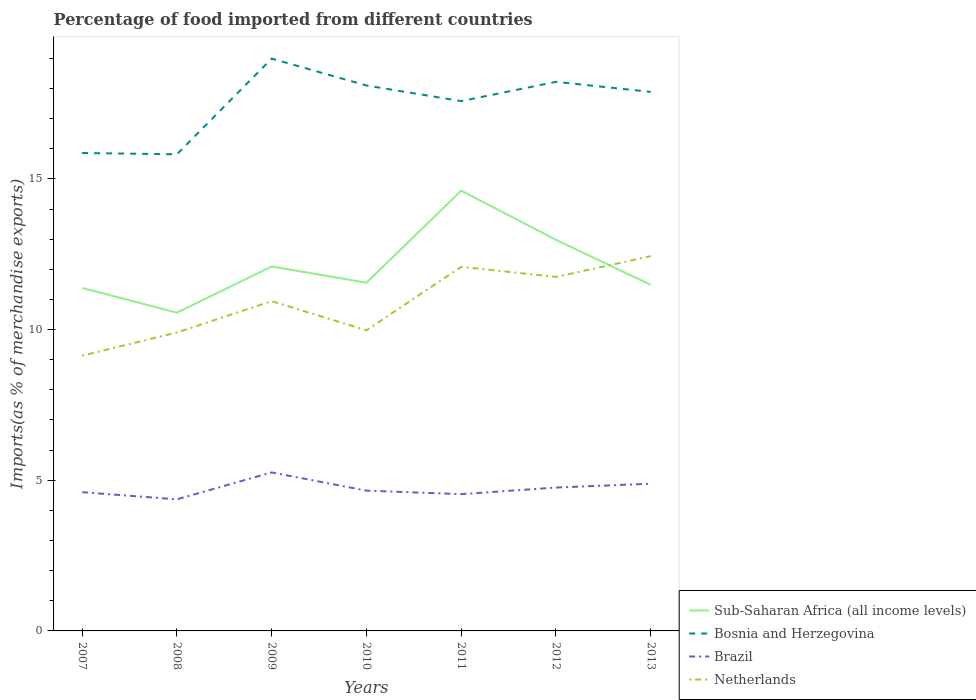Does the line corresponding to Netherlands intersect with the line corresponding to Sub-Saharan Africa (all income levels)?
Offer a very short reply. Yes. Is the number of lines equal to the number of legend labels?
Offer a very short reply. Yes. Across all years, what is the maximum percentage of imports to different countries in Brazil?
Your answer should be compact. 4.37. In which year was the percentage of imports to different countries in Bosnia and Herzegovina maximum?
Provide a short and direct response. 2008. What is the total percentage of imports to different countries in Sub-Saharan Africa (all income levels) in the graph?
Ensure brevity in your answer.  -0.17. What is the difference between the highest and the second highest percentage of imports to different countries in Sub-Saharan Africa (all income levels)?
Your answer should be very brief. 4.05. How many lines are there?
Offer a terse response. 4. How many years are there in the graph?
Make the answer very short. 7. Does the graph contain any zero values?
Provide a short and direct response. No. Does the graph contain grids?
Your answer should be compact. No. How are the legend labels stacked?
Ensure brevity in your answer.  Vertical. What is the title of the graph?
Provide a succinct answer. Percentage of food imported from different countries. What is the label or title of the X-axis?
Give a very brief answer. Years. What is the label or title of the Y-axis?
Make the answer very short. Imports(as % of merchandise exports). What is the Imports(as % of merchandise exports) of Sub-Saharan Africa (all income levels) in 2007?
Keep it short and to the point. 11.38. What is the Imports(as % of merchandise exports) in Bosnia and Herzegovina in 2007?
Offer a very short reply. 15.86. What is the Imports(as % of merchandise exports) of Brazil in 2007?
Keep it short and to the point. 4.6. What is the Imports(as % of merchandise exports) of Netherlands in 2007?
Keep it short and to the point. 9.13. What is the Imports(as % of merchandise exports) in Sub-Saharan Africa (all income levels) in 2008?
Provide a succinct answer. 10.56. What is the Imports(as % of merchandise exports) in Bosnia and Herzegovina in 2008?
Provide a short and direct response. 15.82. What is the Imports(as % of merchandise exports) of Brazil in 2008?
Provide a short and direct response. 4.37. What is the Imports(as % of merchandise exports) in Netherlands in 2008?
Your answer should be compact. 9.9. What is the Imports(as % of merchandise exports) of Sub-Saharan Africa (all income levels) in 2009?
Offer a terse response. 12.09. What is the Imports(as % of merchandise exports) in Bosnia and Herzegovina in 2009?
Offer a terse response. 18.99. What is the Imports(as % of merchandise exports) in Brazil in 2009?
Ensure brevity in your answer.  5.26. What is the Imports(as % of merchandise exports) in Netherlands in 2009?
Provide a succinct answer. 10.94. What is the Imports(as % of merchandise exports) of Sub-Saharan Africa (all income levels) in 2010?
Your answer should be very brief. 11.55. What is the Imports(as % of merchandise exports) in Bosnia and Herzegovina in 2010?
Ensure brevity in your answer.  18.1. What is the Imports(as % of merchandise exports) in Brazil in 2010?
Make the answer very short. 4.65. What is the Imports(as % of merchandise exports) of Netherlands in 2010?
Make the answer very short. 9.97. What is the Imports(as % of merchandise exports) in Sub-Saharan Africa (all income levels) in 2011?
Offer a terse response. 14.61. What is the Imports(as % of merchandise exports) of Bosnia and Herzegovina in 2011?
Your answer should be compact. 17.58. What is the Imports(as % of merchandise exports) of Brazil in 2011?
Provide a succinct answer. 4.54. What is the Imports(as % of merchandise exports) of Netherlands in 2011?
Provide a short and direct response. 12.08. What is the Imports(as % of merchandise exports) of Sub-Saharan Africa (all income levels) in 2012?
Give a very brief answer. 12.98. What is the Imports(as % of merchandise exports) in Bosnia and Herzegovina in 2012?
Provide a short and direct response. 18.22. What is the Imports(as % of merchandise exports) in Brazil in 2012?
Your response must be concise. 4.76. What is the Imports(as % of merchandise exports) in Netherlands in 2012?
Offer a very short reply. 11.75. What is the Imports(as % of merchandise exports) of Sub-Saharan Africa (all income levels) in 2013?
Provide a short and direct response. 11.48. What is the Imports(as % of merchandise exports) in Bosnia and Herzegovina in 2013?
Ensure brevity in your answer.  17.89. What is the Imports(as % of merchandise exports) in Brazil in 2013?
Give a very brief answer. 4.88. What is the Imports(as % of merchandise exports) in Netherlands in 2013?
Your answer should be very brief. 12.44. Across all years, what is the maximum Imports(as % of merchandise exports) in Sub-Saharan Africa (all income levels)?
Ensure brevity in your answer.  14.61. Across all years, what is the maximum Imports(as % of merchandise exports) in Bosnia and Herzegovina?
Provide a short and direct response. 18.99. Across all years, what is the maximum Imports(as % of merchandise exports) of Brazil?
Your answer should be compact. 5.26. Across all years, what is the maximum Imports(as % of merchandise exports) in Netherlands?
Your answer should be very brief. 12.44. Across all years, what is the minimum Imports(as % of merchandise exports) in Sub-Saharan Africa (all income levels)?
Give a very brief answer. 10.56. Across all years, what is the minimum Imports(as % of merchandise exports) in Bosnia and Herzegovina?
Ensure brevity in your answer.  15.82. Across all years, what is the minimum Imports(as % of merchandise exports) of Brazil?
Make the answer very short. 4.37. Across all years, what is the minimum Imports(as % of merchandise exports) of Netherlands?
Give a very brief answer. 9.13. What is the total Imports(as % of merchandise exports) in Sub-Saharan Africa (all income levels) in the graph?
Ensure brevity in your answer.  84.66. What is the total Imports(as % of merchandise exports) of Bosnia and Herzegovina in the graph?
Your answer should be very brief. 122.45. What is the total Imports(as % of merchandise exports) in Brazil in the graph?
Provide a succinct answer. 33.06. What is the total Imports(as % of merchandise exports) in Netherlands in the graph?
Offer a terse response. 76.22. What is the difference between the Imports(as % of merchandise exports) of Sub-Saharan Africa (all income levels) in 2007 and that in 2008?
Your response must be concise. 0.82. What is the difference between the Imports(as % of merchandise exports) in Bosnia and Herzegovina in 2007 and that in 2008?
Keep it short and to the point. 0.04. What is the difference between the Imports(as % of merchandise exports) in Brazil in 2007 and that in 2008?
Your answer should be very brief. 0.24. What is the difference between the Imports(as % of merchandise exports) in Netherlands in 2007 and that in 2008?
Your response must be concise. -0.77. What is the difference between the Imports(as % of merchandise exports) in Sub-Saharan Africa (all income levels) in 2007 and that in 2009?
Your answer should be compact. -0.71. What is the difference between the Imports(as % of merchandise exports) of Bosnia and Herzegovina in 2007 and that in 2009?
Make the answer very short. -3.13. What is the difference between the Imports(as % of merchandise exports) of Brazil in 2007 and that in 2009?
Offer a very short reply. -0.66. What is the difference between the Imports(as % of merchandise exports) of Netherlands in 2007 and that in 2009?
Your answer should be compact. -1.81. What is the difference between the Imports(as % of merchandise exports) of Sub-Saharan Africa (all income levels) in 2007 and that in 2010?
Give a very brief answer. -0.17. What is the difference between the Imports(as % of merchandise exports) of Bosnia and Herzegovina in 2007 and that in 2010?
Make the answer very short. -2.24. What is the difference between the Imports(as % of merchandise exports) in Brazil in 2007 and that in 2010?
Your answer should be compact. -0.05. What is the difference between the Imports(as % of merchandise exports) of Netherlands in 2007 and that in 2010?
Provide a short and direct response. -0.84. What is the difference between the Imports(as % of merchandise exports) of Sub-Saharan Africa (all income levels) in 2007 and that in 2011?
Keep it short and to the point. -3.23. What is the difference between the Imports(as % of merchandise exports) of Bosnia and Herzegovina in 2007 and that in 2011?
Offer a terse response. -1.72. What is the difference between the Imports(as % of merchandise exports) of Brazil in 2007 and that in 2011?
Give a very brief answer. 0.06. What is the difference between the Imports(as % of merchandise exports) in Netherlands in 2007 and that in 2011?
Your answer should be very brief. -2.95. What is the difference between the Imports(as % of merchandise exports) of Sub-Saharan Africa (all income levels) in 2007 and that in 2012?
Your answer should be very brief. -1.6. What is the difference between the Imports(as % of merchandise exports) in Bosnia and Herzegovina in 2007 and that in 2012?
Your response must be concise. -2.36. What is the difference between the Imports(as % of merchandise exports) in Brazil in 2007 and that in 2012?
Keep it short and to the point. -0.15. What is the difference between the Imports(as % of merchandise exports) of Netherlands in 2007 and that in 2012?
Give a very brief answer. -2.61. What is the difference between the Imports(as % of merchandise exports) of Sub-Saharan Africa (all income levels) in 2007 and that in 2013?
Your answer should be compact. -0.1. What is the difference between the Imports(as % of merchandise exports) in Bosnia and Herzegovina in 2007 and that in 2013?
Your answer should be compact. -2.03. What is the difference between the Imports(as % of merchandise exports) in Brazil in 2007 and that in 2013?
Your response must be concise. -0.28. What is the difference between the Imports(as % of merchandise exports) of Netherlands in 2007 and that in 2013?
Your response must be concise. -3.3. What is the difference between the Imports(as % of merchandise exports) in Sub-Saharan Africa (all income levels) in 2008 and that in 2009?
Provide a short and direct response. -1.53. What is the difference between the Imports(as % of merchandise exports) of Bosnia and Herzegovina in 2008 and that in 2009?
Your response must be concise. -3.17. What is the difference between the Imports(as % of merchandise exports) of Brazil in 2008 and that in 2009?
Provide a succinct answer. -0.89. What is the difference between the Imports(as % of merchandise exports) in Netherlands in 2008 and that in 2009?
Your answer should be very brief. -1.04. What is the difference between the Imports(as % of merchandise exports) in Sub-Saharan Africa (all income levels) in 2008 and that in 2010?
Keep it short and to the point. -0.99. What is the difference between the Imports(as % of merchandise exports) of Bosnia and Herzegovina in 2008 and that in 2010?
Offer a very short reply. -2.28. What is the difference between the Imports(as % of merchandise exports) of Brazil in 2008 and that in 2010?
Your answer should be very brief. -0.29. What is the difference between the Imports(as % of merchandise exports) in Netherlands in 2008 and that in 2010?
Ensure brevity in your answer.  -0.07. What is the difference between the Imports(as % of merchandise exports) of Sub-Saharan Africa (all income levels) in 2008 and that in 2011?
Keep it short and to the point. -4.05. What is the difference between the Imports(as % of merchandise exports) in Bosnia and Herzegovina in 2008 and that in 2011?
Give a very brief answer. -1.76. What is the difference between the Imports(as % of merchandise exports) in Brazil in 2008 and that in 2011?
Your answer should be compact. -0.17. What is the difference between the Imports(as % of merchandise exports) of Netherlands in 2008 and that in 2011?
Offer a terse response. -2.18. What is the difference between the Imports(as % of merchandise exports) in Sub-Saharan Africa (all income levels) in 2008 and that in 2012?
Ensure brevity in your answer.  -2.42. What is the difference between the Imports(as % of merchandise exports) in Bosnia and Herzegovina in 2008 and that in 2012?
Offer a terse response. -2.4. What is the difference between the Imports(as % of merchandise exports) in Brazil in 2008 and that in 2012?
Give a very brief answer. -0.39. What is the difference between the Imports(as % of merchandise exports) of Netherlands in 2008 and that in 2012?
Provide a succinct answer. -1.84. What is the difference between the Imports(as % of merchandise exports) of Sub-Saharan Africa (all income levels) in 2008 and that in 2013?
Provide a short and direct response. -0.92. What is the difference between the Imports(as % of merchandise exports) in Bosnia and Herzegovina in 2008 and that in 2013?
Offer a terse response. -2.07. What is the difference between the Imports(as % of merchandise exports) in Brazil in 2008 and that in 2013?
Provide a succinct answer. -0.52. What is the difference between the Imports(as % of merchandise exports) in Netherlands in 2008 and that in 2013?
Your answer should be very brief. -2.53. What is the difference between the Imports(as % of merchandise exports) of Sub-Saharan Africa (all income levels) in 2009 and that in 2010?
Provide a succinct answer. 0.54. What is the difference between the Imports(as % of merchandise exports) in Bosnia and Herzegovina in 2009 and that in 2010?
Offer a very short reply. 0.89. What is the difference between the Imports(as % of merchandise exports) in Brazil in 2009 and that in 2010?
Keep it short and to the point. 0.6. What is the difference between the Imports(as % of merchandise exports) in Sub-Saharan Africa (all income levels) in 2009 and that in 2011?
Keep it short and to the point. -2.52. What is the difference between the Imports(as % of merchandise exports) in Bosnia and Herzegovina in 2009 and that in 2011?
Your answer should be compact. 1.41. What is the difference between the Imports(as % of merchandise exports) in Brazil in 2009 and that in 2011?
Your answer should be compact. 0.72. What is the difference between the Imports(as % of merchandise exports) in Netherlands in 2009 and that in 2011?
Keep it short and to the point. -1.14. What is the difference between the Imports(as % of merchandise exports) in Sub-Saharan Africa (all income levels) in 2009 and that in 2012?
Make the answer very short. -0.88. What is the difference between the Imports(as % of merchandise exports) of Bosnia and Herzegovina in 2009 and that in 2012?
Your response must be concise. 0.77. What is the difference between the Imports(as % of merchandise exports) of Brazil in 2009 and that in 2012?
Keep it short and to the point. 0.5. What is the difference between the Imports(as % of merchandise exports) in Netherlands in 2009 and that in 2012?
Ensure brevity in your answer.  -0.8. What is the difference between the Imports(as % of merchandise exports) in Sub-Saharan Africa (all income levels) in 2009 and that in 2013?
Your response must be concise. 0.61. What is the difference between the Imports(as % of merchandise exports) of Bosnia and Herzegovina in 2009 and that in 2013?
Your answer should be very brief. 1.1. What is the difference between the Imports(as % of merchandise exports) of Brazil in 2009 and that in 2013?
Make the answer very short. 0.38. What is the difference between the Imports(as % of merchandise exports) of Netherlands in 2009 and that in 2013?
Offer a very short reply. -1.49. What is the difference between the Imports(as % of merchandise exports) of Sub-Saharan Africa (all income levels) in 2010 and that in 2011?
Your answer should be very brief. -3.05. What is the difference between the Imports(as % of merchandise exports) in Bosnia and Herzegovina in 2010 and that in 2011?
Keep it short and to the point. 0.52. What is the difference between the Imports(as % of merchandise exports) in Brazil in 2010 and that in 2011?
Offer a terse response. 0.12. What is the difference between the Imports(as % of merchandise exports) of Netherlands in 2010 and that in 2011?
Offer a terse response. -2.11. What is the difference between the Imports(as % of merchandise exports) of Sub-Saharan Africa (all income levels) in 2010 and that in 2012?
Make the answer very short. -1.42. What is the difference between the Imports(as % of merchandise exports) in Bosnia and Herzegovina in 2010 and that in 2012?
Keep it short and to the point. -0.12. What is the difference between the Imports(as % of merchandise exports) in Brazil in 2010 and that in 2012?
Make the answer very short. -0.1. What is the difference between the Imports(as % of merchandise exports) of Netherlands in 2010 and that in 2012?
Ensure brevity in your answer.  -1.77. What is the difference between the Imports(as % of merchandise exports) in Sub-Saharan Africa (all income levels) in 2010 and that in 2013?
Your response must be concise. 0.07. What is the difference between the Imports(as % of merchandise exports) in Bosnia and Herzegovina in 2010 and that in 2013?
Offer a terse response. 0.21. What is the difference between the Imports(as % of merchandise exports) in Brazil in 2010 and that in 2013?
Your answer should be compact. -0.23. What is the difference between the Imports(as % of merchandise exports) of Netherlands in 2010 and that in 2013?
Offer a very short reply. -2.46. What is the difference between the Imports(as % of merchandise exports) of Sub-Saharan Africa (all income levels) in 2011 and that in 2012?
Your answer should be very brief. 1.63. What is the difference between the Imports(as % of merchandise exports) of Bosnia and Herzegovina in 2011 and that in 2012?
Your response must be concise. -0.64. What is the difference between the Imports(as % of merchandise exports) in Brazil in 2011 and that in 2012?
Provide a short and direct response. -0.22. What is the difference between the Imports(as % of merchandise exports) of Netherlands in 2011 and that in 2012?
Provide a short and direct response. 0.33. What is the difference between the Imports(as % of merchandise exports) in Sub-Saharan Africa (all income levels) in 2011 and that in 2013?
Your response must be concise. 3.13. What is the difference between the Imports(as % of merchandise exports) in Bosnia and Herzegovina in 2011 and that in 2013?
Keep it short and to the point. -0.31. What is the difference between the Imports(as % of merchandise exports) in Brazil in 2011 and that in 2013?
Your answer should be very brief. -0.35. What is the difference between the Imports(as % of merchandise exports) of Netherlands in 2011 and that in 2013?
Your answer should be very brief. -0.35. What is the difference between the Imports(as % of merchandise exports) of Sub-Saharan Africa (all income levels) in 2012 and that in 2013?
Offer a very short reply. 1.49. What is the difference between the Imports(as % of merchandise exports) of Bosnia and Herzegovina in 2012 and that in 2013?
Keep it short and to the point. 0.33. What is the difference between the Imports(as % of merchandise exports) of Brazil in 2012 and that in 2013?
Offer a terse response. -0.13. What is the difference between the Imports(as % of merchandise exports) of Netherlands in 2012 and that in 2013?
Provide a short and direct response. -0.69. What is the difference between the Imports(as % of merchandise exports) of Sub-Saharan Africa (all income levels) in 2007 and the Imports(as % of merchandise exports) of Bosnia and Herzegovina in 2008?
Your response must be concise. -4.43. What is the difference between the Imports(as % of merchandise exports) of Sub-Saharan Africa (all income levels) in 2007 and the Imports(as % of merchandise exports) of Brazil in 2008?
Give a very brief answer. 7.01. What is the difference between the Imports(as % of merchandise exports) in Sub-Saharan Africa (all income levels) in 2007 and the Imports(as % of merchandise exports) in Netherlands in 2008?
Offer a very short reply. 1.48. What is the difference between the Imports(as % of merchandise exports) of Bosnia and Herzegovina in 2007 and the Imports(as % of merchandise exports) of Brazil in 2008?
Give a very brief answer. 11.49. What is the difference between the Imports(as % of merchandise exports) of Bosnia and Herzegovina in 2007 and the Imports(as % of merchandise exports) of Netherlands in 2008?
Your answer should be compact. 5.96. What is the difference between the Imports(as % of merchandise exports) of Brazil in 2007 and the Imports(as % of merchandise exports) of Netherlands in 2008?
Your answer should be very brief. -5.3. What is the difference between the Imports(as % of merchandise exports) in Sub-Saharan Africa (all income levels) in 2007 and the Imports(as % of merchandise exports) in Bosnia and Herzegovina in 2009?
Make the answer very short. -7.61. What is the difference between the Imports(as % of merchandise exports) of Sub-Saharan Africa (all income levels) in 2007 and the Imports(as % of merchandise exports) of Brazil in 2009?
Your answer should be compact. 6.12. What is the difference between the Imports(as % of merchandise exports) in Sub-Saharan Africa (all income levels) in 2007 and the Imports(as % of merchandise exports) in Netherlands in 2009?
Your answer should be very brief. 0.44. What is the difference between the Imports(as % of merchandise exports) in Bosnia and Herzegovina in 2007 and the Imports(as % of merchandise exports) in Brazil in 2009?
Offer a very short reply. 10.6. What is the difference between the Imports(as % of merchandise exports) of Bosnia and Herzegovina in 2007 and the Imports(as % of merchandise exports) of Netherlands in 2009?
Your answer should be very brief. 4.92. What is the difference between the Imports(as % of merchandise exports) in Brazil in 2007 and the Imports(as % of merchandise exports) in Netherlands in 2009?
Give a very brief answer. -6.34. What is the difference between the Imports(as % of merchandise exports) of Sub-Saharan Africa (all income levels) in 2007 and the Imports(as % of merchandise exports) of Bosnia and Herzegovina in 2010?
Your response must be concise. -6.72. What is the difference between the Imports(as % of merchandise exports) of Sub-Saharan Africa (all income levels) in 2007 and the Imports(as % of merchandise exports) of Brazil in 2010?
Provide a succinct answer. 6.73. What is the difference between the Imports(as % of merchandise exports) in Sub-Saharan Africa (all income levels) in 2007 and the Imports(as % of merchandise exports) in Netherlands in 2010?
Offer a very short reply. 1.41. What is the difference between the Imports(as % of merchandise exports) of Bosnia and Herzegovina in 2007 and the Imports(as % of merchandise exports) of Brazil in 2010?
Offer a very short reply. 11.2. What is the difference between the Imports(as % of merchandise exports) in Bosnia and Herzegovina in 2007 and the Imports(as % of merchandise exports) in Netherlands in 2010?
Ensure brevity in your answer.  5.88. What is the difference between the Imports(as % of merchandise exports) of Brazil in 2007 and the Imports(as % of merchandise exports) of Netherlands in 2010?
Give a very brief answer. -5.37. What is the difference between the Imports(as % of merchandise exports) in Sub-Saharan Africa (all income levels) in 2007 and the Imports(as % of merchandise exports) in Bosnia and Herzegovina in 2011?
Keep it short and to the point. -6.2. What is the difference between the Imports(as % of merchandise exports) in Sub-Saharan Africa (all income levels) in 2007 and the Imports(as % of merchandise exports) in Brazil in 2011?
Give a very brief answer. 6.84. What is the difference between the Imports(as % of merchandise exports) of Sub-Saharan Africa (all income levels) in 2007 and the Imports(as % of merchandise exports) of Netherlands in 2011?
Your answer should be very brief. -0.7. What is the difference between the Imports(as % of merchandise exports) in Bosnia and Herzegovina in 2007 and the Imports(as % of merchandise exports) in Brazil in 2011?
Keep it short and to the point. 11.32. What is the difference between the Imports(as % of merchandise exports) in Bosnia and Herzegovina in 2007 and the Imports(as % of merchandise exports) in Netherlands in 2011?
Your answer should be compact. 3.78. What is the difference between the Imports(as % of merchandise exports) of Brazil in 2007 and the Imports(as % of merchandise exports) of Netherlands in 2011?
Your response must be concise. -7.48. What is the difference between the Imports(as % of merchandise exports) of Sub-Saharan Africa (all income levels) in 2007 and the Imports(as % of merchandise exports) of Bosnia and Herzegovina in 2012?
Your answer should be compact. -6.84. What is the difference between the Imports(as % of merchandise exports) in Sub-Saharan Africa (all income levels) in 2007 and the Imports(as % of merchandise exports) in Brazil in 2012?
Offer a terse response. 6.62. What is the difference between the Imports(as % of merchandise exports) in Sub-Saharan Africa (all income levels) in 2007 and the Imports(as % of merchandise exports) in Netherlands in 2012?
Ensure brevity in your answer.  -0.37. What is the difference between the Imports(as % of merchandise exports) in Bosnia and Herzegovina in 2007 and the Imports(as % of merchandise exports) in Brazil in 2012?
Your answer should be compact. 11.1. What is the difference between the Imports(as % of merchandise exports) of Bosnia and Herzegovina in 2007 and the Imports(as % of merchandise exports) of Netherlands in 2012?
Keep it short and to the point. 4.11. What is the difference between the Imports(as % of merchandise exports) in Brazil in 2007 and the Imports(as % of merchandise exports) in Netherlands in 2012?
Provide a short and direct response. -7.14. What is the difference between the Imports(as % of merchandise exports) of Sub-Saharan Africa (all income levels) in 2007 and the Imports(as % of merchandise exports) of Bosnia and Herzegovina in 2013?
Offer a terse response. -6.5. What is the difference between the Imports(as % of merchandise exports) of Sub-Saharan Africa (all income levels) in 2007 and the Imports(as % of merchandise exports) of Brazil in 2013?
Your answer should be very brief. 6.5. What is the difference between the Imports(as % of merchandise exports) of Sub-Saharan Africa (all income levels) in 2007 and the Imports(as % of merchandise exports) of Netherlands in 2013?
Ensure brevity in your answer.  -1.05. What is the difference between the Imports(as % of merchandise exports) in Bosnia and Herzegovina in 2007 and the Imports(as % of merchandise exports) in Brazil in 2013?
Your answer should be very brief. 10.97. What is the difference between the Imports(as % of merchandise exports) in Bosnia and Herzegovina in 2007 and the Imports(as % of merchandise exports) in Netherlands in 2013?
Your response must be concise. 3.42. What is the difference between the Imports(as % of merchandise exports) of Brazil in 2007 and the Imports(as % of merchandise exports) of Netherlands in 2013?
Your answer should be very brief. -7.83. What is the difference between the Imports(as % of merchandise exports) of Sub-Saharan Africa (all income levels) in 2008 and the Imports(as % of merchandise exports) of Bosnia and Herzegovina in 2009?
Give a very brief answer. -8.43. What is the difference between the Imports(as % of merchandise exports) of Sub-Saharan Africa (all income levels) in 2008 and the Imports(as % of merchandise exports) of Brazil in 2009?
Ensure brevity in your answer.  5.3. What is the difference between the Imports(as % of merchandise exports) in Sub-Saharan Africa (all income levels) in 2008 and the Imports(as % of merchandise exports) in Netherlands in 2009?
Your answer should be compact. -0.38. What is the difference between the Imports(as % of merchandise exports) in Bosnia and Herzegovina in 2008 and the Imports(as % of merchandise exports) in Brazil in 2009?
Provide a short and direct response. 10.56. What is the difference between the Imports(as % of merchandise exports) in Bosnia and Herzegovina in 2008 and the Imports(as % of merchandise exports) in Netherlands in 2009?
Offer a very short reply. 4.87. What is the difference between the Imports(as % of merchandise exports) of Brazil in 2008 and the Imports(as % of merchandise exports) of Netherlands in 2009?
Your answer should be compact. -6.58. What is the difference between the Imports(as % of merchandise exports) of Sub-Saharan Africa (all income levels) in 2008 and the Imports(as % of merchandise exports) of Bosnia and Herzegovina in 2010?
Your answer should be very brief. -7.54. What is the difference between the Imports(as % of merchandise exports) of Sub-Saharan Africa (all income levels) in 2008 and the Imports(as % of merchandise exports) of Brazil in 2010?
Your answer should be compact. 5.9. What is the difference between the Imports(as % of merchandise exports) in Sub-Saharan Africa (all income levels) in 2008 and the Imports(as % of merchandise exports) in Netherlands in 2010?
Offer a very short reply. 0.59. What is the difference between the Imports(as % of merchandise exports) in Bosnia and Herzegovina in 2008 and the Imports(as % of merchandise exports) in Brazil in 2010?
Provide a short and direct response. 11.16. What is the difference between the Imports(as % of merchandise exports) of Bosnia and Herzegovina in 2008 and the Imports(as % of merchandise exports) of Netherlands in 2010?
Give a very brief answer. 5.84. What is the difference between the Imports(as % of merchandise exports) in Brazil in 2008 and the Imports(as % of merchandise exports) in Netherlands in 2010?
Keep it short and to the point. -5.61. What is the difference between the Imports(as % of merchandise exports) of Sub-Saharan Africa (all income levels) in 2008 and the Imports(as % of merchandise exports) of Bosnia and Herzegovina in 2011?
Your response must be concise. -7.02. What is the difference between the Imports(as % of merchandise exports) of Sub-Saharan Africa (all income levels) in 2008 and the Imports(as % of merchandise exports) of Brazil in 2011?
Keep it short and to the point. 6.02. What is the difference between the Imports(as % of merchandise exports) in Sub-Saharan Africa (all income levels) in 2008 and the Imports(as % of merchandise exports) in Netherlands in 2011?
Give a very brief answer. -1.52. What is the difference between the Imports(as % of merchandise exports) in Bosnia and Herzegovina in 2008 and the Imports(as % of merchandise exports) in Brazil in 2011?
Make the answer very short. 11.28. What is the difference between the Imports(as % of merchandise exports) of Bosnia and Herzegovina in 2008 and the Imports(as % of merchandise exports) of Netherlands in 2011?
Ensure brevity in your answer.  3.73. What is the difference between the Imports(as % of merchandise exports) in Brazil in 2008 and the Imports(as % of merchandise exports) in Netherlands in 2011?
Provide a short and direct response. -7.71. What is the difference between the Imports(as % of merchandise exports) of Sub-Saharan Africa (all income levels) in 2008 and the Imports(as % of merchandise exports) of Bosnia and Herzegovina in 2012?
Offer a very short reply. -7.66. What is the difference between the Imports(as % of merchandise exports) of Sub-Saharan Africa (all income levels) in 2008 and the Imports(as % of merchandise exports) of Brazil in 2012?
Offer a terse response. 5.8. What is the difference between the Imports(as % of merchandise exports) of Sub-Saharan Africa (all income levels) in 2008 and the Imports(as % of merchandise exports) of Netherlands in 2012?
Make the answer very short. -1.19. What is the difference between the Imports(as % of merchandise exports) in Bosnia and Herzegovina in 2008 and the Imports(as % of merchandise exports) in Brazil in 2012?
Offer a terse response. 11.06. What is the difference between the Imports(as % of merchandise exports) in Bosnia and Herzegovina in 2008 and the Imports(as % of merchandise exports) in Netherlands in 2012?
Your answer should be very brief. 4.07. What is the difference between the Imports(as % of merchandise exports) of Brazil in 2008 and the Imports(as % of merchandise exports) of Netherlands in 2012?
Your answer should be very brief. -7.38. What is the difference between the Imports(as % of merchandise exports) in Sub-Saharan Africa (all income levels) in 2008 and the Imports(as % of merchandise exports) in Bosnia and Herzegovina in 2013?
Ensure brevity in your answer.  -7.33. What is the difference between the Imports(as % of merchandise exports) in Sub-Saharan Africa (all income levels) in 2008 and the Imports(as % of merchandise exports) in Brazil in 2013?
Offer a terse response. 5.68. What is the difference between the Imports(as % of merchandise exports) of Sub-Saharan Africa (all income levels) in 2008 and the Imports(as % of merchandise exports) of Netherlands in 2013?
Provide a succinct answer. -1.88. What is the difference between the Imports(as % of merchandise exports) of Bosnia and Herzegovina in 2008 and the Imports(as % of merchandise exports) of Brazil in 2013?
Your answer should be very brief. 10.93. What is the difference between the Imports(as % of merchandise exports) in Bosnia and Herzegovina in 2008 and the Imports(as % of merchandise exports) in Netherlands in 2013?
Your answer should be compact. 3.38. What is the difference between the Imports(as % of merchandise exports) in Brazil in 2008 and the Imports(as % of merchandise exports) in Netherlands in 2013?
Your answer should be very brief. -8.07. What is the difference between the Imports(as % of merchandise exports) in Sub-Saharan Africa (all income levels) in 2009 and the Imports(as % of merchandise exports) in Bosnia and Herzegovina in 2010?
Make the answer very short. -6. What is the difference between the Imports(as % of merchandise exports) in Sub-Saharan Africa (all income levels) in 2009 and the Imports(as % of merchandise exports) in Brazil in 2010?
Make the answer very short. 7.44. What is the difference between the Imports(as % of merchandise exports) of Sub-Saharan Africa (all income levels) in 2009 and the Imports(as % of merchandise exports) of Netherlands in 2010?
Your answer should be compact. 2.12. What is the difference between the Imports(as % of merchandise exports) of Bosnia and Herzegovina in 2009 and the Imports(as % of merchandise exports) of Brazil in 2010?
Give a very brief answer. 14.34. What is the difference between the Imports(as % of merchandise exports) in Bosnia and Herzegovina in 2009 and the Imports(as % of merchandise exports) in Netherlands in 2010?
Offer a terse response. 9.02. What is the difference between the Imports(as % of merchandise exports) in Brazil in 2009 and the Imports(as % of merchandise exports) in Netherlands in 2010?
Offer a very short reply. -4.72. What is the difference between the Imports(as % of merchandise exports) in Sub-Saharan Africa (all income levels) in 2009 and the Imports(as % of merchandise exports) in Bosnia and Herzegovina in 2011?
Your answer should be compact. -5.49. What is the difference between the Imports(as % of merchandise exports) of Sub-Saharan Africa (all income levels) in 2009 and the Imports(as % of merchandise exports) of Brazil in 2011?
Provide a short and direct response. 7.55. What is the difference between the Imports(as % of merchandise exports) in Sub-Saharan Africa (all income levels) in 2009 and the Imports(as % of merchandise exports) in Netherlands in 2011?
Offer a terse response. 0.01. What is the difference between the Imports(as % of merchandise exports) of Bosnia and Herzegovina in 2009 and the Imports(as % of merchandise exports) of Brazil in 2011?
Offer a terse response. 14.45. What is the difference between the Imports(as % of merchandise exports) in Bosnia and Herzegovina in 2009 and the Imports(as % of merchandise exports) in Netherlands in 2011?
Provide a short and direct response. 6.91. What is the difference between the Imports(as % of merchandise exports) in Brazil in 2009 and the Imports(as % of merchandise exports) in Netherlands in 2011?
Give a very brief answer. -6.82. What is the difference between the Imports(as % of merchandise exports) in Sub-Saharan Africa (all income levels) in 2009 and the Imports(as % of merchandise exports) in Bosnia and Herzegovina in 2012?
Give a very brief answer. -6.13. What is the difference between the Imports(as % of merchandise exports) of Sub-Saharan Africa (all income levels) in 2009 and the Imports(as % of merchandise exports) of Brazil in 2012?
Give a very brief answer. 7.34. What is the difference between the Imports(as % of merchandise exports) of Sub-Saharan Africa (all income levels) in 2009 and the Imports(as % of merchandise exports) of Netherlands in 2012?
Provide a short and direct response. 0.35. What is the difference between the Imports(as % of merchandise exports) in Bosnia and Herzegovina in 2009 and the Imports(as % of merchandise exports) in Brazil in 2012?
Provide a short and direct response. 14.23. What is the difference between the Imports(as % of merchandise exports) of Bosnia and Herzegovina in 2009 and the Imports(as % of merchandise exports) of Netherlands in 2012?
Offer a very short reply. 7.24. What is the difference between the Imports(as % of merchandise exports) in Brazil in 2009 and the Imports(as % of merchandise exports) in Netherlands in 2012?
Give a very brief answer. -6.49. What is the difference between the Imports(as % of merchandise exports) in Sub-Saharan Africa (all income levels) in 2009 and the Imports(as % of merchandise exports) in Bosnia and Herzegovina in 2013?
Make the answer very short. -5.79. What is the difference between the Imports(as % of merchandise exports) in Sub-Saharan Africa (all income levels) in 2009 and the Imports(as % of merchandise exports) in Brazil in 2013?
Your answer should be compact. 7.21. What is the difference between the Imports(as % of merchandise exports) in Sub-Saharan Africa (all income levels) in 2009 and the Imports(as % of merchandise exports) in Netherlands in 2013?
Provide a succinct answer. -0.34. What is the difference between the Imports(as % of merchandise exports) of Bosnia and Herzegovina in 2009 and the Imports(as % of merchandise exports) of Brazil in 2013?
Keep it short and to the point. 14.11. What is the difference between the Imports(as % of merchandise exports) in Bosnia and Herzegovina in 2009 and the Imports(as % of merchandise exports) in Netherlands in 2013?
Give a very brief answer. 6.56. What is the difference between the Imports(as % of merchandise exports) in Brazil in 2009 and the Imports(as % of merchandise exports) in Netherlands in 2013?
Your response must be concise. -7.18. What is the difference between the Imports(as % of merchandise exports) of Sub-Saharan Africa (all income levels) in 2010 and the Imports(as % of merchandise exports) of Bosnia and Herzegovina in 2011?
Your response must be concise. -6.03. What is the difference between the Imports(as % of merchandise exports) in Sub-Saharan Africa (all income levels) in 2010 and the Imports(as % of merchandise exports) in Brazil in 2011?
Your answer should be very brief. 7.02. What is the difference between the Imports(as % of merchandise exports) in Sub-Saharan Africa (all income levels) in 2010 and the Imports(as % of merchandise exports) in Netherlands in 2011?
Give a very brief answer. -0.53. What is the difference between the Imports(as % of merchandise exports) of Bosnia and Herzegovina in 2010 and the Imports(as % of merchandise exports) of Brazil in 2011?
Your answer should be compact. 13.56. What is the difference between the Imports(as % of merchandise exports) in Bosnia and Herzegovina in 2010 and the Imports(as % of merchandise exports) in Netherlands in 2011?
Offer a terse response. 6.02. What is the difference between the Imports(as % of merchandise exports) in Brazil in 2010 and the Imports(as % of merchandise exports) in Netherlands in 2011?
Make the answer very short. -7.43. What is the difference between the Imports(as % of merchandise exports) in Sub-Saharan Africa (all income levels) in 2010 and the Imports(as % of merchandise exports) in Bosnia and Herzegovina in 2012?
Give a very brief answer. -6.67. What is the difference between the Imports(as % of merchandise exports) in Sub-Saharan Africa (all income levels) in 2010 and the Imports(as % of merchandise exports) in Brazil in 2012?
Your answer should be very brief. 6.8. What is the difference between the Imports(as % of merchandise exports) of Sub-Saharan Africa (all income levels) in 2010 and the Imports(as % of merchandise exports) of Netherlands in 2012?
Your answer should be very brief. -0.19. What is the difference between the Imports(as % of merchandise exports) of Bosnia and Herzegovina in 2010 and the Imports(as % of merchandise exports) of Brazil in 2012?
Make the answer very short. 13.34. What is the difference between the Imports(as % of merchandise exports) of Bosnia and Herzegovina in 2010 and the Imports(as % of merchandise exports) of Netherlands in 2012?
Offer a terse response. 6.35. What is the difference between the Imports(as % of merchandise exports) in Brazil in 2010 and the Imports(as % of merchandise exports) in Netherlands in 2012?
Keep it short and to the point. -7.09. What is the difference between the Imports(as % of merchandise exports) of Sub-Saharan Africa (all income levels) in 2010 and the Imports(as % of merchandise exports) of Bosnia and Herzegovina in 2013?
Provide a succinct answer. -6.33. What is the difference between the Imports(as % of merchandise exports) of Sub-Saharan Africa (all income levels) in 2010 and the Imports(as % of merchandise exports) of Brazil in 2013?
Keep it short and to the point. 6.67. What is the difference between the Imports(as % of merchandise exports) of Sub-Saharan Africa (all income levels) in 2010 and the Imports(as % of merchandise exports) of Netherlands in 2013?
Offer a very short reply. -0.88. What is the difference between the Imports(as % of merchandise exports) in Bosnia and Herzegovina in 2010 and the Imports(as % of merchandise exports) in Brazil in 2013?
Keep it short and to the point. 13.21. What is the difference between the Imports(as % of merchandise exports) in Bosnia and Herzegovina in 2010 and the Imports(as % of merchandise exports) in Netherlands in 2013?
Provide a succinct answer. 5.66. What is the difference between the Imports(as % of merchandise exports) of Brazil in 2010 and the Imports(as % of merchandise exports) of Netherlands in 2013?
Your response must be concise. -7.78. What is the difference between the Imports(as % of merchandise exports) in Sub-Saharan Africa (all income levels) in 2011 and the Imports(as % of merchandise exports) in Bosnia and Herzegovina in 2012?
Offer a very short reply. -3.61. What is the difference between the Imports(as % of merchandise exports) of Sub-Saharan Africa (all income levels) in 2011 and the Imports(as % of merchandise exports) of Brazil in 2012?
Keep it short and to the point. 9.85. What is the difference between the Imports(as % of merchandise exports) in Sub-Saharan Africa (all income levels) in 2011 and the Imports(as % of merchandise exports) in Netherlands in 2012?
Your answer should be very brief. 2.86. What is the difference between the Imports(as % of merchandise exports) of Bosnia and Herzegovina in 2011 and the Imports(as % of merchandise exports) of Brazil in 2012?
Make the answer very short. 12.82. What is the difference between the Imports(as % of merchandise exports) in Bosnia and Herzegovina in 2011 and the Imports(as % of merchandise exports) in Netherlands in 2012?
Provide a short and direct response. 5.83. What is the difference between the Imports(as % of merchandise exports) in Brazil in 2011 and the Imports(as % of merchandise exports) in Netherlands in 2012?
Keep it short and to the point. -7.21. What is the difference between the Imports(as % of merchandise exports) in Sub-Saharan Africa (all income levels) in 2011 and the Imports(as % of merchandise exports) in Bosnia and Herzegovina in 2013?
Your answer should be very brief. -3.28. What is the difference between the Imports(as % of merchandise exports) of Sub-Saharan Africa (all income levels) in 2011 and the Imports(as % of merchandise exports) of Brazil in 2013?
Provide a short and direct response. 9.72. What is the difference between the Imports(as % of merchandise exports) in Sub-Saharan Africa (all income levels) in 2011 and the Imports(as % of merchandise exports) in Netherlands in 2013?
Provide a short and direct response. 2.17. What is the difference between the Imports(as % of merchandise exports) in Bosnia and Herzegovina in 2011 and the Imports(as % of merchandise exports) in Brazil in 2013?
Ensure brevity in your answer.  12.7. What is the difference between the Imports(as % of merchandise exports) of Bosnia and Herzegovina in 2011 and the Imports(as % of merchandise exports) of Netherlands in 2013?
Provide a short and direct response. 5.14. What is the difference between the Imports(as % of merchandise exports) in Brazil in 2011 and the Imports(as % of merchandise exports) in Netherlands in 2013?
Your answer should be very brief. -7.9. What is the difference between the Imports(as % of merchandise exports) of Sub-Saharan Africa (all income levels) in 2012 and the Imports(as % of merchandise exports) of Bosnia and Herzegovina in 2013?
Your response must be concise. -4.91. What is the difference between the Imports(as % of merchandise exports) in Sub-Saharan Africa (all income levels) in 2012 and the Imports(as % of merchandise exports) in Brazil in 2013?
Provide a short and direct response. 8.09. What is the difference between the Imports(as % of merchandise exports) of Sub-Saharan Africa (all income levels) in 2012 and the Imports(as % of merchandise exports) of Netherlands in 2013?
Your answer should be compact. 0.54. What is the difference between the Imports(as % of merchandise exports) in Bosnia and Herzegovina in 2012 and the Imports(as % of merchandise exports) in Brazil in 2013?
Offer a terse response. 13.34. What is the difference between the Imports(as % of merchandise exports) in Bosnia and Herzegovina in 2012 and the Imports(as % of merchandise exports) in Netherlands in 2013?
Make the answer very short. 5.78. What is the difference between the Imports(as % of merchandise exports) in Brazil in 2012 and the Imports(as % of merchandise exports) in Netherlands in 2013?
Provide a succinct answer. -7.68. What is the average Imports(as % of merchandise exports) of Sub-Saharan Africa (all income levels) per year?
Your answer should be compact. 12.09. What is the average Imports(as % of merchandise exports) of Bosnia and Herzegovina per year?
Keep it short and to the point. 17.49. What is the average Imports(as % of merchandise exports) in Brazil per year?
Offer a terse response. 4.72. What is the average Imports(as % of merchandise exports) in Netherlands per year?
Provide a succinct answer. 10.89. In the year 2007, what is the difference between the Imports(as % of merchandise exports) of Sub-Saharan Africa (all income levels) and Imports(as % of merchandise exports) of Bosnia and Herzegovina?
Your answer should be very brief. -4.48. In the year 2007, what is the difference between the Imports(as % of merchandise exports) of Sub-Saharan Africa (all income levels) and Imports(as % of merchandise exports) of Brazil?
Keep it short and to the point. 6.78. In the year 2007, what is the difference between the Imports(as % of merchandise exports) of Sub-Saharan Africa (all income levels) and Imports(as % of merchandise exports) of Netherlands?
Provide a short and direct response. 2.25. In the year 2007, what is the difference between the Imports(as % of merchandise exports) in Bosnia and Herzegovina and Imports(as % of merchandise exports) in Brazil?
Make the answer very short. 11.26. In the year 2007, what is the difference between the Imports(as % of merchandise exports) in Bosnia and Herzegovina and Imports(as % of merchandise exports) in Netherlands?
Give a very brief answer. 6.72. In the year 2007, what is the difference between the Imports(as % of merchandise exports) of Brazil and Imports(as % of merchandise exports) of Netherlands?
Offer a terse response. -4.53. In the year 2008, what is the difference between the Imports(as % of merchandise exports) in Sub-Saharan Africa (all income levels) and Imports(as % of merchandise exports) in Bosnia and Herzegovina?
Give a very brief answer. -5.26. In the year 2008, what is the difference between the Imports(as % of merchandise exports) in Sub-Saharan Africa (all income levels) and Imports(as % of merchandise exports) in Brazil?
Keep it short and to the point. 6.19. In the year 2008, what is the difference between the Imports(as % of merchandise exports) of Sub-Saharan Africa (all income levels) and Imports(as % of merchandise exports) of Netherlands?
Keep it short and to the point. 0.66. In the year 2008, what is the difference between the Imports(as % of merchandise exports) of Bosnia and Herzegovina and Imports(as % of merchandise exports) of Brazil?
Ensure brevity in your answer.  11.45. In the year 2008, what is the difference between the Imports(as % of merchandise exports) in Bosnia and Herzegovina and Imports(as % of merchandise exports) in Netherlands?
Make the answer very short. 5.91. In the year 2008, what is the difference between the Imports(as % of merchandise exports) of Brazil and Imports(as % of merchandise exports) of Netherlands?
Give a very brief answer. -5.54. In the year 2009, what is the difference between the Imports(as % of merchandise exports) in Sub-Saharan Africa (all income levels) and Imports(as % of merchandise exports) in Bosnia and Herzegovina?
Provide a succinct answer. -6.9. In the year 2009, what is the difference between the Imports(as % of merchandise exports) in Sub-Saharan Africa (all income levels) and Imports(as % of merchandise exports) in Brazil?
Make the answer very short. 6.83. In the year 2009, what is the difference between the Imports(as % of merchandise exports) of Sub-Saharan Africa (all income levels) and Imports(as % of merchandise exports) of Netherlands?
Your response must be concise. 1.15. In the year 2009, what is the difference between the Imports(as % of merchandise exports) of Bosnia and Herzegovina and Imports(as % of merchandise exports) of Brazil?
Offer a terse response. 13.73. In the year 2009, what is the difference between the Imports(as % of merchandise exports) of Bosnia and Herzegovina and Imports(as % of merchandise exports) of Netherlands?
Your answer should be compact. 8.05. In the year 2009, what is the difference between the Imports(as % of merchandise exports) of Brazil and Imports(as % of merchandise exports) of Netherlands?
Make the answer very short. -5.68. In the year 2010, what is the difference between the Imports(as % of merchandise exports) in Sub-Saharan Africa (all income levels) and Imports(as % of merchandise exports) in Bosnia and Herzegovina?
Your answer should be compact. -6.54. In the year 2010, what is the difference between the Imports(as % of merchandise exports) in Sub-Saharan Africa (all income levels) and Imports(as % of merchandise exports) in Brazil?
Ensure brevity in your answer.  6.9. In the year 2010, what is the difference between the Imports(as % of merchandise exports) in Sub-Saharan Africa (all income levels) and Imports(as % of merchandise exports) in Netherlands?
Provide a succinct answer. 1.58. In the year 2010, what is the difference between the Imports(as % of merchandise exports) of Bosnia and Herzegovina and Imports(as % of merchandise exports) of Brazil?
Keep it short and to the point. 13.44. In the year 2010, what is the difference between the Imports(as % of merchandise exports) in Bosnia and Herzegovina and Imports(as % of merchandise exports) in Netherlands?
Give a very brief answer. 8.12. In the year 2010, what is the difference between the Imports(as % of merchandise exports) of Brazil and Imports(as % of merchandise exports) of Netherlands?
Provide a short and direct response. -5.32. In the year 2011, what is the difference between the Imports(as % of merchandise exports) in Sub-Saharan Africa (all income levels) and Imports(as % of merchandise exports) in Bosnia and Herzegovina?
Give a very brief answer. -2.97. In the year 2011, what is the difference between the Imports(as % of merchandise exports) in Sub-Saharan Africa (all income levels) and Imports(as % of merchandise exports) in Brazil?
Provide a succinct answer. 10.07. In the year 2011, what is the difference between the Imports(as % of merchandise exports) of Sub-Saharan Africa (all income levels) and Imports(as % of merchandise exports) of Netherlands?
Make the answer very short. 2.53. In the year 2011, what is the difference between the Imports(as % of merchandise exports) of Bosnia and Herzegovina and Imports(as % of merchandise exports) of Brazil?
Give a very brief answer. 13.04. In the year 2011, what is the difference between the Imports(as % of merchandise exports) in Bosnia and Herzegovina and Imports(as % of merchandise exports) in Netherlands?
Offer a terse response. 5.5. In the year 2011, what is the difference between the Imports(as % of merchandise exports) in Brazil and Imports(as % of merchandise exports) in Netherlands?
Ensure brevity in your answer.  -7.54. In the year 2012, what is the difference between the Imports(as % of merchandise exports) of Sub-Saharan Africa (all income levels) and Imports(as % of merchandise exports) of Bosnia and Herzegovina?
Give a very brief answer. -5.24. In the year 2012, what is the difference between the Imports(as % of merchandise exports) in Sub-Saharan Africa (all income levels) and Imports(as % of merchandise exports) in Brazil?
Make the answer very short. 8.22. In the year 2012, what is the difference between the Imports(as % of merchandise exports) in Sub-Saharan Africa (all income levels) and Imports(as % of merchandise exports) in Netherlands?
Give a very brief answer. 1.23. In the year 2012, what is the difference between the Imports(as % of merchandise exports) of Bosnia and Herzegovina and Imports(as % of merchandise exports) of Brazil?
Provide a succinct answer. 13.46. In the year 2012, what is the difference between the Imports(as % of merchandise exports) in Bosnia and Herzegovina and Imports(as % of merchandise exports) in Netherlands?
Your answer should be compact. 6.47. In the year 2012, what is the difference between the Imports(as % of merchandise exports) of Brazil and Imports(as % of merchandise exports) of Netherlands?
Make the answer very short. -6.99. In the year 2013, what is the difference between the Imports(as % of merchandise exports) of Sub-Saharan Africa (all income levels) and Imports(as % of merchandise exports) of Bosnia and Herzegovina?
Provide a succinct answer. -6.4. In the year 2013, what is the difference between the Imports(as % of merchandise exports) in Sub-Saharan Africa (all income levels) and Imports(as % of merchandise exports) in Brazil?
Make the answer very short. 6.6. In the year 2013, what is the difference between the Imports(as % of merchandise exports) in Sub-Saharan Africa (all income levels) and Imports(as % of merchandise exports) in Netherlands?
Offer a terse response. -0.95. In the year 2013, what is the difference between the Imports(as % of merchandise exports) in Bosnia and Herzegovina and Imports(as % of merchandise exports) in Brazil?
Provide a succinct answer. 13. In the year 2013, what is the difference between the Imports(as % of merchandise exports) of Bosnia and Herzegovina and Imports(as % of merchandise exports) of Netherlands?
Make the answer very short. 5.45. In the year 2013, what is the difference between the Imports(as % of merchandise exports) in Brazil and Imports(as % of merchandise exports) in Netherlands?
Your answer should be compact. -7.55. What is the ratio of the Imports(as % of merchandise exports) of Sub-Saharan Africa (all income levels) in 2007 to that in 2008?
Your answer should be very brief. 1.08. What is the ratio of the Imports(as % of merchandise exports) of Bosnia and Herzegovina in 2007 to that in 2008?
Ensure brevity in your answer.  1. What is the ratio of the Imports(as % of merchandise exports) in Brazil in 2007 to that in 2008?
Give a very brief answer. 1.05. What is the ratio of the Imports(as % of merchandise exports) of Netherlands in 2007 to that in 2008?
Ensure brevity in your answer.  0.92. What is the ratio of the Imports(as % of merchandise exports) of Sub-Saharan Africa (all income levels) in 2007 to that in 2009?
Ensure brevity in your answer.  0.94. What is the ratio of the Imports(as % of merchandise exports) of Bosnia and Herzegovina in 2007 to that in 2009?
Your response must be concise. 0.84. What is the ratio of the Imports(as % of merchandise exports) of Brazil in 2007 to that in 2009?
Provide a short and direct response. 0.88. What is the ratio of the Imports(as % of merchandise exports) in Netherlands in 2007 to that in 2009?
Provide a succinct answer. 0.83. What is the ratio of the Imports(as % of merchandise exports) in Sub-Saharan Africa (all income levels) in 2007 to that in 2010?
Offer a terse response. 0.98. What is the ratio of the Imports(as % of merchandise exports) of Bosnia and Herzegovina in 2007 to that in 2010?
Make the answer very short. 0.88. What is the ratio of the Imports(as % of merchandise exports) of Brazil in 2007 to that in 2010?
Keep it short and to the point. 0.99. What is the ratio of the Imports(as % of merchandise exports) of Netherlands in 2007 to that in 2010?
Make the answer very short. 0.92. What is the ratio of the Imports(as % of merchandise exports) of Sub-Saharan Africa (all income levels) in 2007 to that in 2011?
Provide a succinct answer. 0.78. What is the ratio of the Imports(as % of merchandise exports) of Bosnia and Herzegovina in 2007 to that in 2011?
Give a very brief answer. 0.9. What is the ratio of the Imports(as % of merchandise exports) in Brazil in 2007 to that in 2011?
Offer a terse response. 1.01. What is the ratio of the Imports(as % of merchandise exports) in Netherlands in 2007 to that in 2011?
Your answer should be very brief. 0.76. What is the ratio of the Imports(as % of merchandise exports) of Sub-Saharan Africa (all income levels) in 2007 to that in 2012?
Your answer should be very brief. 0.88. What is the ratio of the Imports(as % of merchandise exports) of Bosnia and Herzegovina in 2007 to that in 2012?
Offer a very short reply. 0.87. What is the ratio of the Imports(as % of merchandise exports) of Brazil in 2007 to that in 2012?
Ensure brevity in your answer.  0.97. What is the ratio of the Imports(as % of merchandise exports) of Netherlands in 2007 to that in 2012?
Offer a very short reply. 0.78. What is the ratio of the Imports(as % of merchandise exports) of Bosnia and Herzegovina in 2007 to that in 2013?
Your answer should be compact. 0.89. What is the ratio of the Imports(as % of merchandise exports) in Brazil in 2007 to that in 2013?
Your response must be concise. 0.94. What is the ratio of the Imports(as % of merchandise exports) in Netherlands in 2007 to that in 2013?
Make the answer very short. 0.73. What is the ratio of the Imports(as % of merchandise exports) in Sub-Saharan Africa (all income levels) in 2008 to that in 2009?
Your response must be concise. 0.87. What is the ratio of the Imports(as % of merchandise exports) of Bosnia and Herzegovina in 2008 to that in 2009?
Offer a very short reply. 0.83. What is the ratio of the Imports(as % of merchandise exports) of Brazil in 2008 to that in 2009?
Provide a succinct answer. 0.83. What is the ratio of the Imports(as % of merchandise exports) in Netherlands in 2008 to that in 2009?
Make the answer very short. 0.9. What is the ratio of the Imports(as % of merchandise exports) in Sub-Saharan Africa (all income levels) in 2008 to that in 2010?
Offer a very short reply. 0.91. What is the ratio of the Imports(as % of merchandise exports) of Bosnia and Herzegovina in 2008 to that in 2010?
Ensure brevity in your answer.  0.87. What is the ratio of the Imports(as % of merchandise exports) of Brazil in 2008 to that in 2010?
Your response must be concise. 0.94. What is the ratio of the Imports(as % of merchandise exports) of Sub-Saharan Africa (all income levels) in 2008 to that in 2011?
Make the answer very short. 0.72. What is the ratio of the Imports(as % of merchandise exports) of Bosnia and Herzegovina in 2008 to that in 2011?
Your answer should be very brief. 0.9. What is the ratio of the Imports(as % of merchandise exports) in Brazil in 2008 to that in 2011?
Your answer should be compact. 0.96. What is the ratio of the Imports(as % of merchandise exports) in Netherlands in 2008 to that in 2011?
Make the answer very short. 0.82. What is the ratio of the Imports(as % of merchandise exports) of Sub-Saharan Africa (all income levels) in 2008 to that in 2012?
Offer a terse response. 0.81. What is the ratio of the Imports(as % of merchandise exports) in Bosnia and Herzegovina in 2008 to that in 2012?
Provide a succinct answer. 0.87. What is the ratio of the Imports(as % of merchandise exports) of Brazil in 2008 to that in 2012?
Your answer should be compact. 0.92. What is the ratio of the Imports(as % of merchandise exports) in Netherlands in 2008 to that in 2012?
Offer a terse response. 0.84. What is the ratio of the Imports(as % of merchandise exports) in Sub-Saharan Africa (all income levels) in 2008 to that in 2013?
Provide a short and direct response. 0.92. What is the ratio of the Imports(as % of merchandise exports) in Bosnia and Herzegovina in 2008 to that in 2013?
Offer a terse response. 0.88. What is the ratio of the Imports(as % of merchandise exports) in Brazil in 2008 to that in 2013?
Provide a short and direct response. 0.89. What is the ratio of the Imports(as % of merchandise exports) in Netherlands in 2008 to that in 2013?
Provide a short and direct response. 0.8. What is the ratio of the Imports(as % of merchandise exports) in Sub-Saharan Africa (all income levels) in 2009 to that in 2010?
Offer a very short reply. 1.05. What is the ratio of the Imports(as % of merchandise exports) in Bosnia and Herzegovina in 2009 to that in 2010?
Provide a succinct answer. 1.05. What is the ratio of the Imports(as % of merchandise exports) of Brazil in 2009 to that in 2010?
Ensure brevity in your answer.  1.13. What is the ratio of the Imports(as % of merchandise exports) in Netherlands in 2009 to that in 2010?
Provide a short and direct response. 1.1. What is the ratio of the Imports(as % of merchandise exports) in Sub-Saharan Africa (all income levels) in 2009 to that in 2011?
Provide a short and direct response. 0.83. What is the ratio of the Imports(as % of merchandise exports) of Bosnia and Herzegovina in 2009 to that in 2011?
Your response must be concise. 1.08. What is the ratio of the Imports(as % of merchandise exports) in Brazil in 2009 to that in 2011?
Provide a succinct answer. 1.16. What is the ratio of the Imports(as % of merchandise exports) in Netherlands in 2009 to that in 2011?
Make the answer very short. 0.91. What is the ratio of the Imports(as % of merchandise exports) in Sub-Saharan Africa (all income levels) in 2009 to that in 2012?
Offer a terse response. 0.93. What is the ratio of the Imports(as % of merchandise exports) in Bosnia and Herzegovina in 2009 to that in 2012?
Give a very brief answer. 1.04. What is the ratio of the Imports(as % of merchandise exports) in Brazil in 2009 to that in 2012?
Provide a succinct answer. 1.11. What is the ratio of the Imports(as % of merchandise exports) of Netherlands in 2009 to that in 2012?
Keep it short and to the point. 0.93. What is the ratio of the Imports(as % of merchandise exports) of Sub-Saharan Africa (all income levels) in 2009 to that in 2013?
Give a very brief answer. 1.05. What is the ratio of the Imports(as % of merchandise exports) of Bosnia and Herzegovina in 2009 to that in 2013?
Your response must be concise. 1.06. What is the ratio of the Imports(as % of merchandise exports) of Brazil in 2009 to that in 2013?
Provide a short and direct response. 1.08. What is the ratio of the Imports(as % of merchandise exports) in Netherlands in 2009 to that in 2013?
Keep it short and to the point. 0.88. What is the ratio of the Imports(as % of merchandise exports) of Sub-Saharan Africa (all income levels) in 2010 to that in 2011?
Your response must be concise. 0.79. What is the ratio of the Imports(as % of merchandise exports) of Bosnia and Herzegovina in 2010 to that in 2011?
Provide a succinct answer. 1.03. What is the ratio of the Imports(as % of merchandise exports) in Brazil in 2010 to that in 2011?
Provide a short and direct response. 1.03. What is the ratio of the Imports(as % of merchandise exports) of Netherlands in 2010 to that in 2011?
Keep it short and to the point. 0.83. What is the ratio of the Imports(as % of merchandise exports) in Sub-Saharan Africa (all income levels) in 2010 to that in 2012?
Give a very brief answer. 0.89. What is the ratio of the Imports(as % of merchandise exports) in Bosnia and Herzegovina in 2010 to that in 2012?
Your answer should be compact. 0.99. What is the ratio of the Imports(as % of merchandise exports) in Brazil in 2010 to that in 2012?
Provide a succinct answer. 0.98. What is the ratio of the Imports(as % of merchandise exports) in Netherlands in 2010 to that in 2012?
Provide a succinct answer. 0.85. What is the ratio of the Imports(as % of merchandise exports) of Bosnia and Herzegovina in 2010 to that in 2013?
Your answer should be very brief. 1.01. What is the ratio of the Imports(as % of merchandise exports) of Brazil in 2010 to that in 2013?
Provide a succinct answer. 0.95. What is the ratio of the Imports(as % of merchandise exports) of Netherlands in 2010 to that in 2013?
Your answer should be compact. 0.8. What is the ratio of the Imports(as % of merchandise exports) in Sub-Saharan Africa (all income levels) in 2011 to that in 2012?
Your answer should be compact. 1.13. What is the ratio of the Imports(as % of merchandise exports) in Bosnia and Herzegovina in 2011 to that in 2012?
Your answer should be compact. 0.96. What is the ratio of the Imports(as % of merchandise exports) of Brazil in 2011 to that in 2012?
Give a very brief answer. 0.95. What is the ratio of the Imports(as % of merchandise exports) in Netherlands in 2011 to that in 2012?
Provide a short and direct response. 1.03. What is the ratio of the Imports(as % of merchandise exports) in Sub-Saharan Africa (all income levels) in 2011 to that in 2013?
Keep it short and to the point. 1.27. What is the ratio of the Imports(as % of merchandise exports) in Bosnia and Herzegovina in 2011 to that in 2013?
Offer a very short reply. 0.98. What is the ratio of the Imports(as % of merchandise exports) in Brazil in 2011 to that in 2013?
Your answer should be compact. 0.93. What is the ratio of the Imports(as % of merchandise exports) of Netherlands in 2011 to that in 2013?
Ensure brevity in your answer.  0.97. What is the ratio of the Imports(as % of merchandise exports) in Sub-Saharan Africa (all income levels) in 2012 to that in 2013?
Make the answer very short. 1.13. What is the ratio of the Imports(as % of merchandise exports) in Bosnia and Herzegovina in 2012 to that in 2013?
Offer a terse response. 1.02. What is the ratio of the Imports(as % of merchandise exports) of Brazil in 2012 to that in 2013?
Make the answer very short. 0.97. What is the ratio of the Imports(as % of merchandise exports) of Netherlands in 2012 to that in 2013?
Your answer should be very brief. 0.94. What is the difference between the highest and the second highest Imports(as % of merchandise exports) of Sub-Saharan Africa (all income levels)?
Keep it short and to the point. 1.63. What is the difference between the highest and the second highest Imports(as % of merchandise exports) in Bosnia and Herzegovina?
Ensure brevity in your answer.  0.77. What is the difference between the highest and the second highest Imports(as % of merchandise exports) of Netherlands?
Provide a short and direct response. 0.35. What is the difference between the highest and the lowest Imports(as % of merchandise exports) of Sub-Saharan Africa (all income levels)?
Provide a short and direct response. 4.05. What is the difference between the highest and the lowest Imports(as % of merchandise exports) in Bosnia and Herzegovina?
Your response must be concise. 3.17. What is the difference between the highest and the lowest Imports(as % of merchandise exports) in Brazil?
Your response must be concise. 0.89. What is the difference between the highest and the lowest Imports(as % of merchandise exports) of Netherlands?
Give a very brief answer. 3.3. 